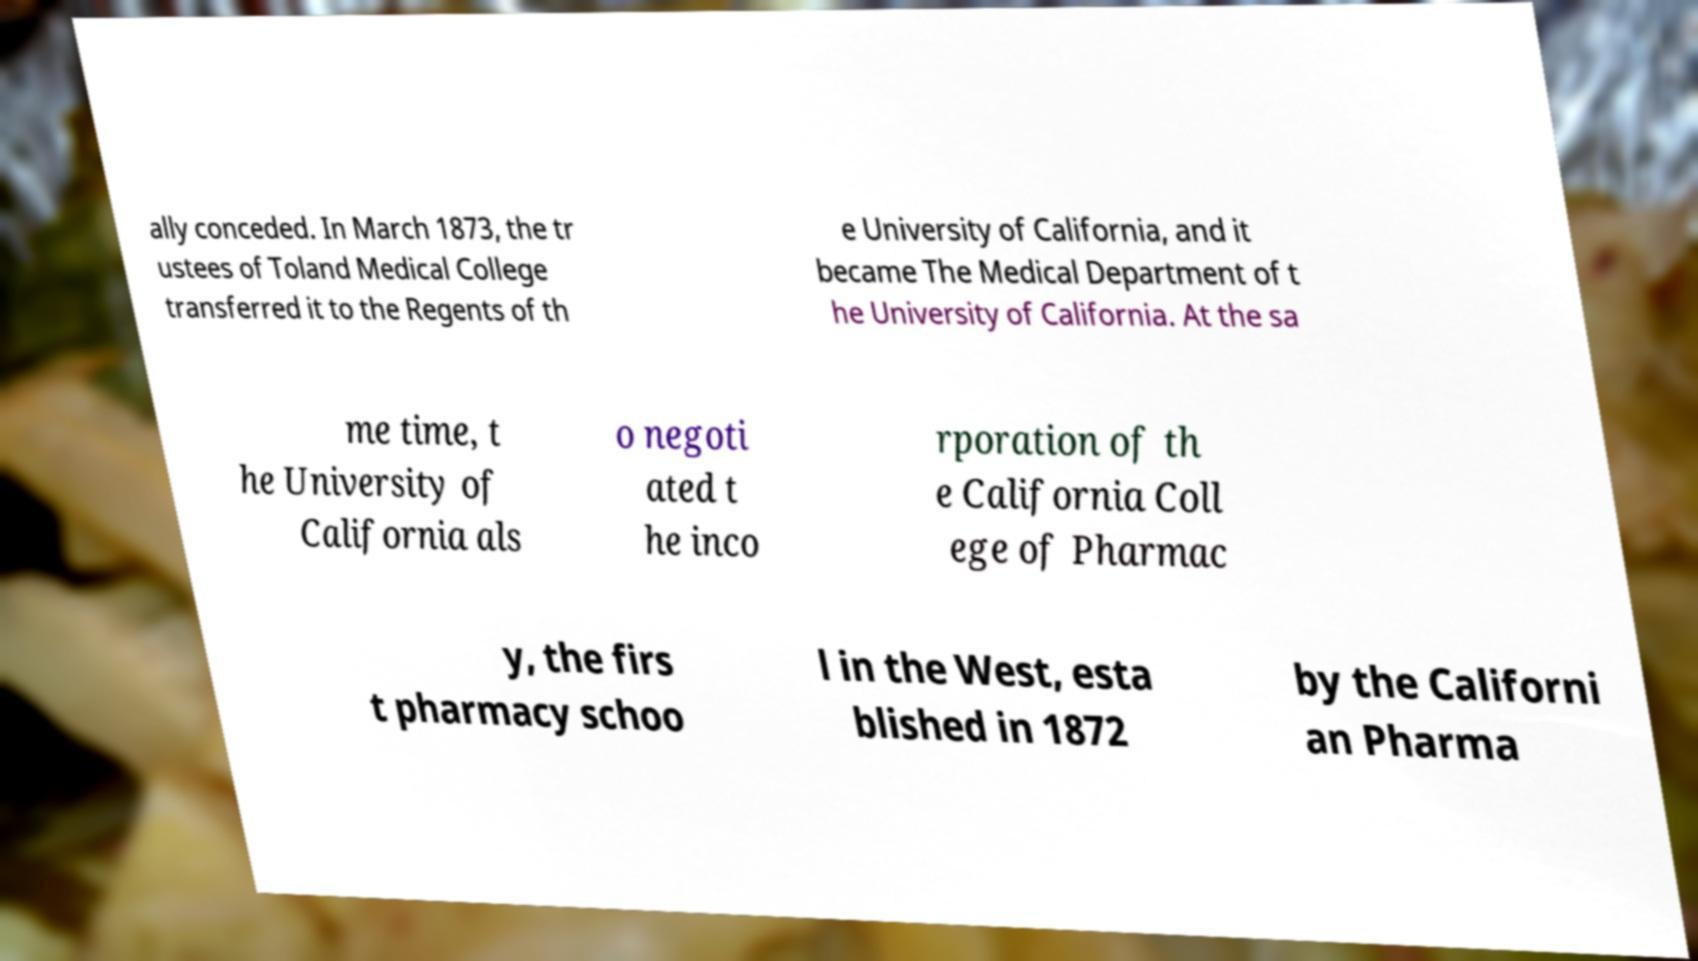What messages or text are displayed in this image? I need them in a readable, typed format. ally conceded. In March 1873, the tr ustees of Toland Medical College transferred it to the Regents of th e University of California, and it became The Medical Department of t he University of California. At the sa me time, t he University of California als o negoti ated t he inco rporation of th e California Coll ege of Pharmac y, the firs t pharmacy schoo l in the West, esta blished in 1872 by the Californi an Pharma 